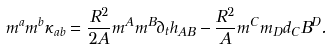Convert formula to latex. <formula><loc_0><loc_0><loc_500><loc_500>m ^ { a } m ^ { b } \kappa _ { a b } = \frac { R ^ { 2 } } { 2 A } m ^ { A } m ^ { B } \partial _ { t } h _ { A B } - \frac { R ^ { 2 } } { A } m ^ { C } m _ { D } d _ { C } B ^ { D } .</formula> 